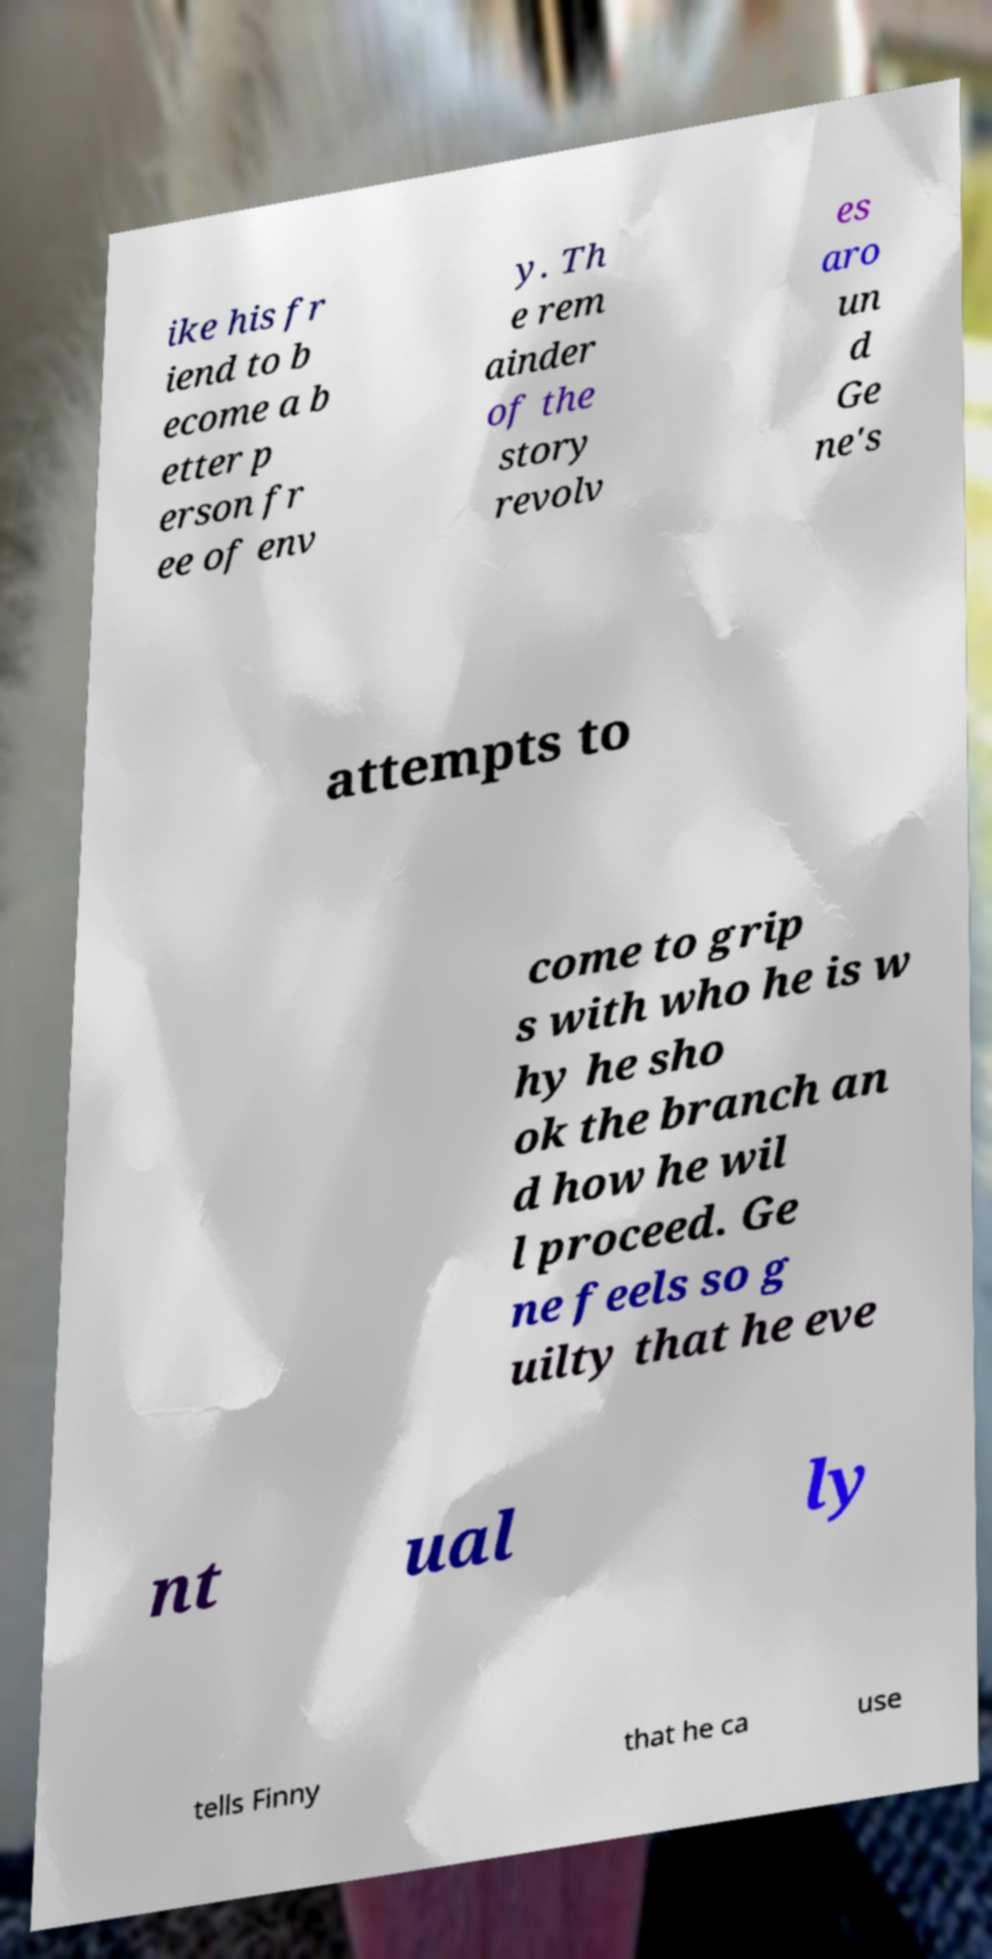Please read and relay the text visible in this image. What does it say? ike his fr iend to b ecome a b etter p erson fr ee of env y. Th e rem ainder of the story revolv es aro un d Ge ne's attempts to come to grip s with who he is w hy he sho ok the branch an d how he wil l proceed. Ge ne feels so g uilty that he eve nt ual ly tells Finny that he ca use 